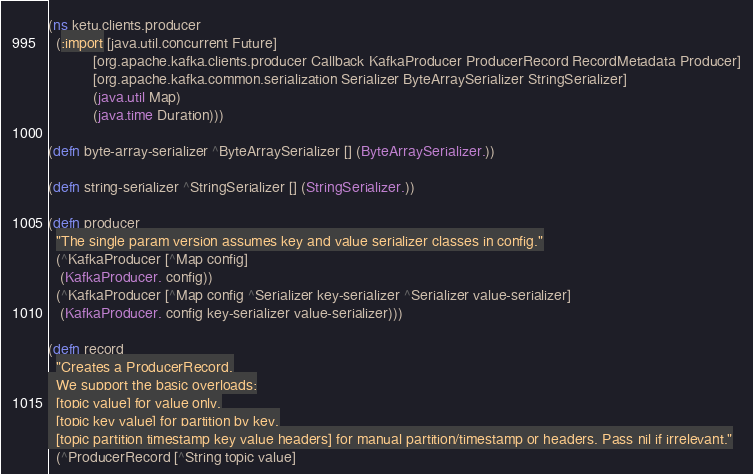<code> <loc_0><loc_0><loc_500><loc_500><_Clojure_>(ns ketu.clients.producer
  (:import [java.util.concurrent Future]
           [org.apache.kafka.clients.producer Callback KafkaProducer ProducerRecord RecordMetadata Producer]
           [org.apache.kafka.common.serialization Serializer ByteArraySerializer StringSerializer]
           (java.util Map)
           (java.time Duration)))

(defn byte-array-serializer ^ByteArraySerializer [] (ByteArraySerializer.))

(defn string-serializer ^StringSerializer [] (StringSerializer.))

(defn producer
  "The single param version assumes key and value serializer classes in config."
  (^KafkaProducer [^Map config]
   (KafkaProducer. config))
  (^KafkaProducer [^Map config ^Serializer key-serializer ^Serializer value-serializer]
   (KafkaProducer. config key-serializer value-serializer)))

(defn record
  "Creates a ProducerRecord.
  We support the basic overloads:
  [topic value] for value only,
  [topic key value] for partition by key,
  [topic partition timestamp key value headers] for manual partition/timestamp or headers. Pass nil if irrelevant."
  (^ProducerRecord [^String topic value]</code> 